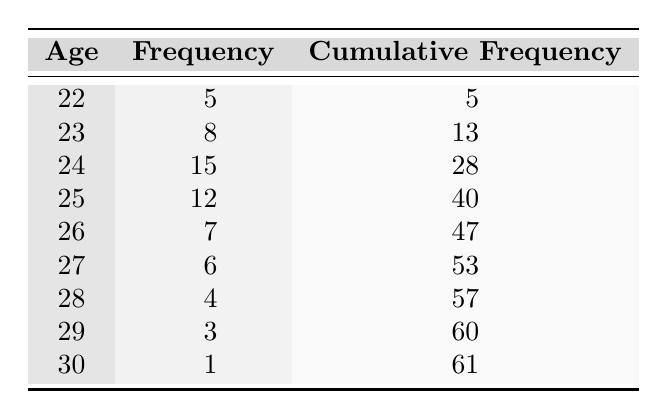What is the frequency of participants aged 24? The table shows that the count for participants aged 24 is listed directly in the column labeled "Frequency". According to the table, the frequency for age 24 is 15.
Answer: 15 What is the cumulative frequency for participants aged 27? The cumulative frequency for age 27 is provided in its corresponding column in the table. The value listed under the cumulative frequency for age 27 is 53.
Answer: 53 How many participants are aged 25 or younger? To find this, I need to sum the frequencies of all ages 25 and younger. From the table, the counts are: 5 (age 22) + 8 (age 23) + 15 (age 24) + 12 (age 25) = 40.
Answer: 40 What is the average age of participants? The average age requires calculating the weighted average, where we multiply each age by its frequency and sum these products, then divide by the total number of participants. The calculations are: (22 * 5) + (23 * 8) + (24 * 15) + (25 * 12) + (26 * 7) + (27 * 6) + (28 * 4) + (29 * 3) + (30 * 1) = 1190. The total number of participants is 61. Hence, the average age is 1190/61 ≈ 19.67.
Answer: 24.51 Is there any participant aged 30? The table indicates the frequency column and explicitly shows that one participant is aged 30, which confirms the existence of a participant in this age group.
Answer: Yes Which age group has the highest count of participants? To determine the highest frequency, I will compare all the frequency counts in the table. The highest count is for age 24 with a frequency of 15 participants, as it is greater than all others.
Answer: Age 24 